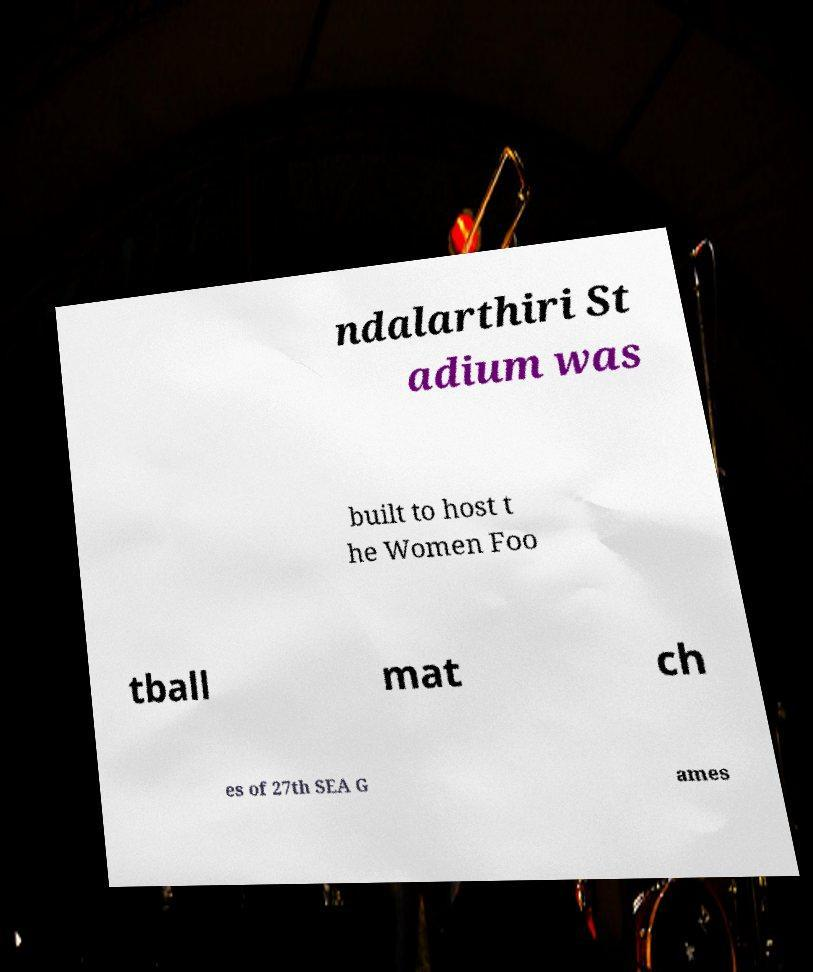Please identify and transcribe the text found in this image. ndalarthiri St adium was built to host t he Women Foo tball mat ch es of 27th SEA G ames 